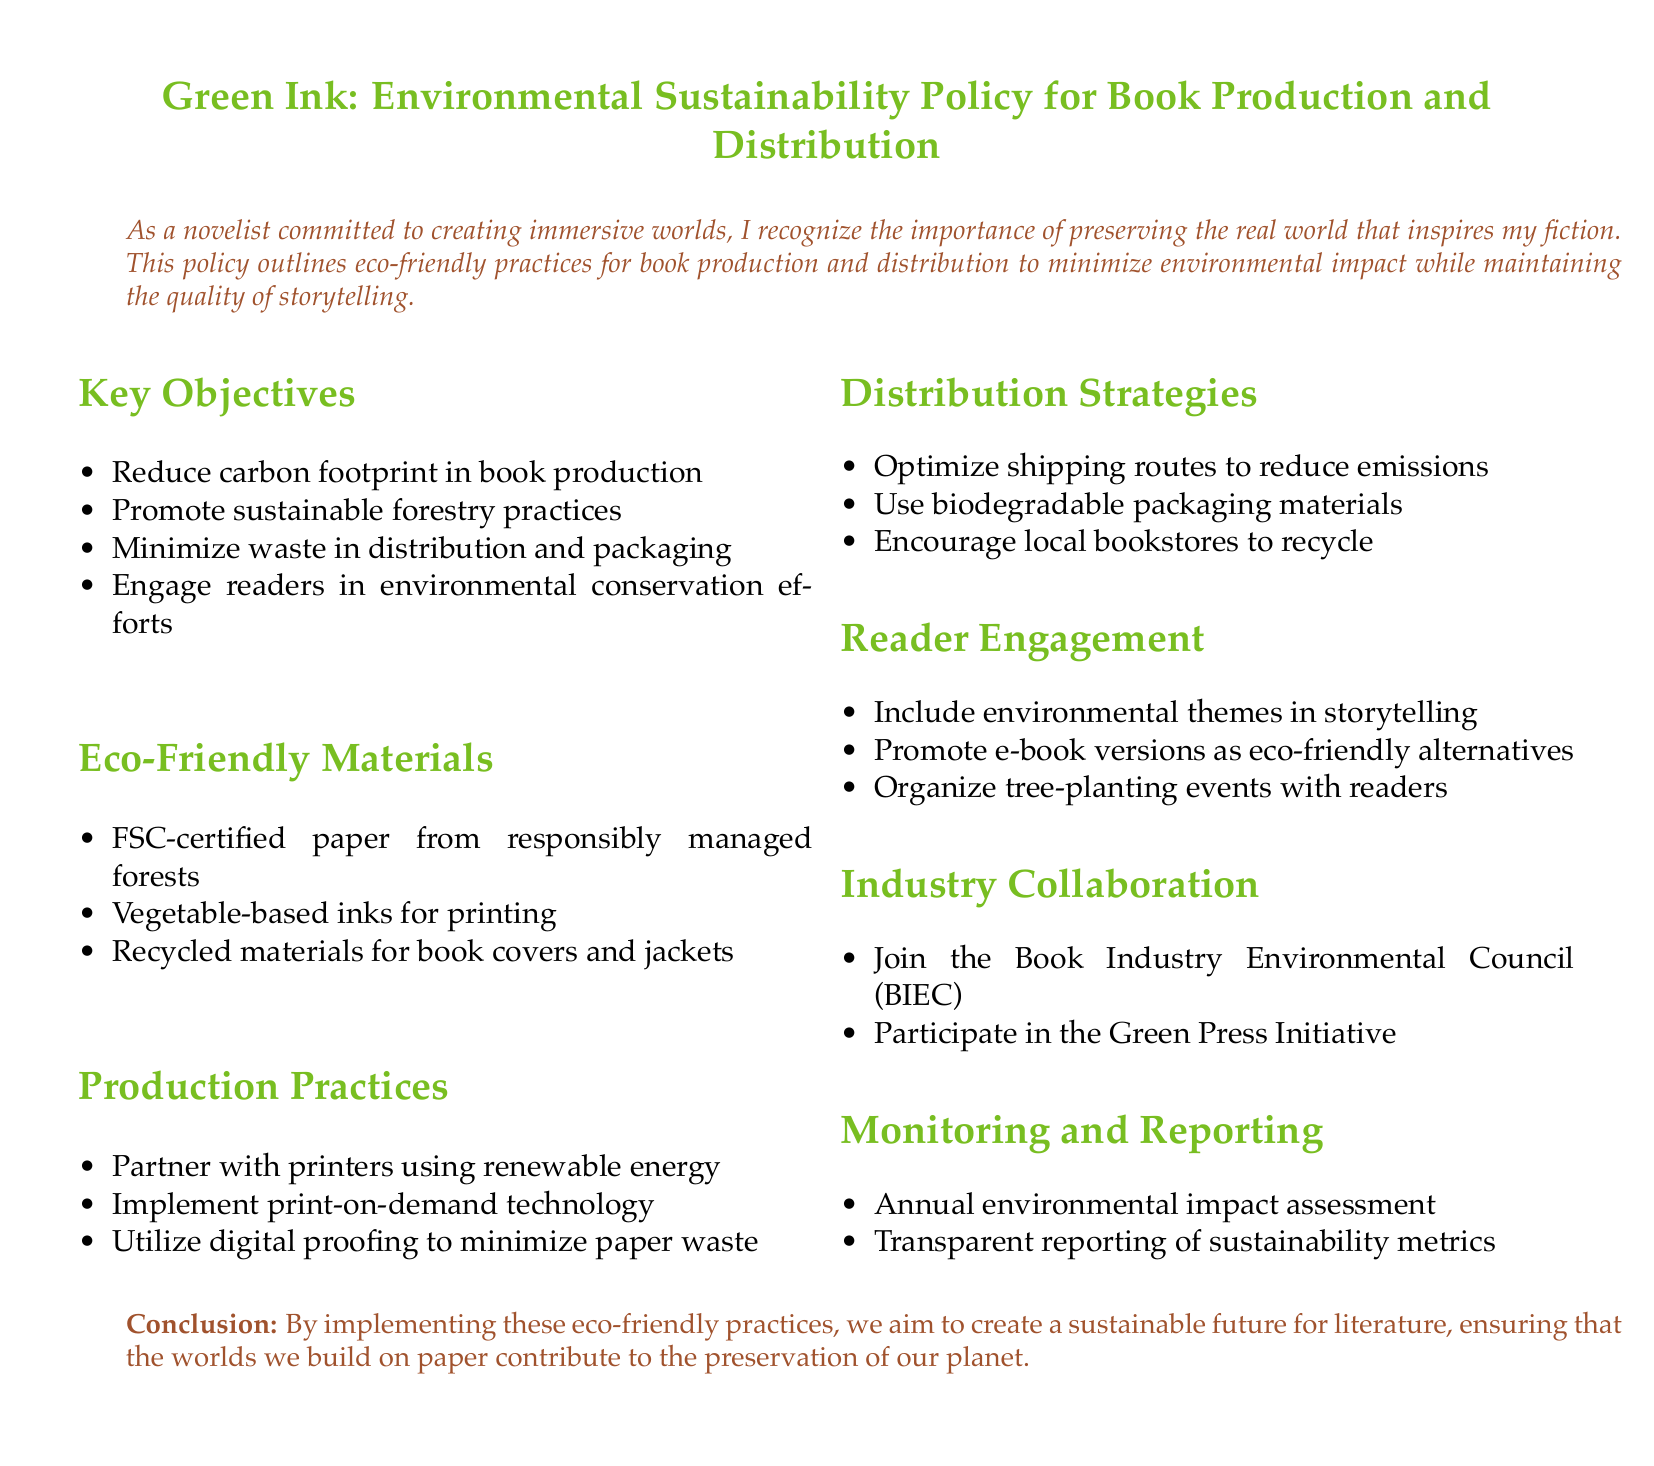What is the main title of the document? The main title is stated at the beginning of the document, focusing on the environmental sustainability policy.
Answer: Green Ink: Environmental Sustainability Policy for Book Production and Distribution What does FSC stand for? The document mentions FSC as part of eco-friendly materials, referring to a certification related to forestry practices.
Answer: Forest Stewardship Council What is one eco-friendly ink type mentioned? The document lists specific types of inks that are used in printing as part of the eco-friendly practices section.
Answer: Vegetable-based inks What is one goal of the distribution strategies? The goals are outlined in the distribution strategies section, focusing on reducing environmental impact.
Answer: Optimize shipping routes to reduce emissions Which industry collaboration initiative is mentioned? The document includes specific initiatives that the organization plans to join for environmental efforts.
Answer: Book Industry Environmental Council (BIEC) What year is the annual environmental impact assessment conducted? The document specifies the frequency of the assessment in the monitoring and reporting section.
Answer: Annual What theme is suggested to include in storytelling? The document encourages integrating specific themes in the narratives as part of reader engagement.
Answer: Environmental themes What is one method to minimize waste in production? The document lists practices aimed at reducing waste in the production process.
Answer: Implement print-on-demand technology What type of materials should packaging be? The distribution strategies section mentions materials that reduce environmental impact.
Answer: Biodegradable packaging materials 